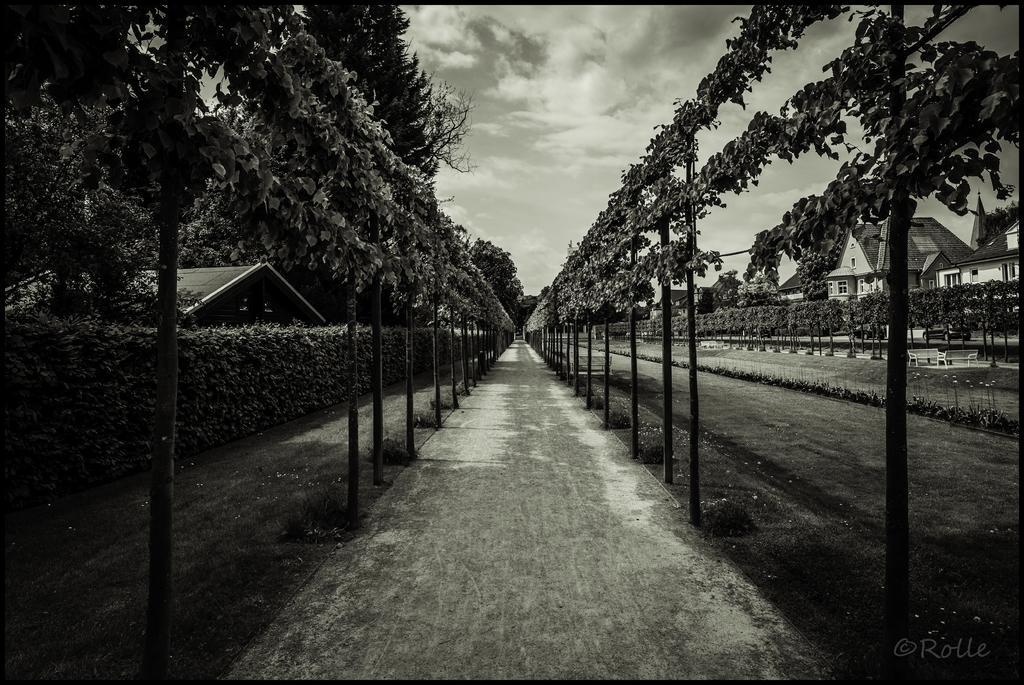Please provide a concise description of this image. In the image we can see there are buildings and trees. Here we can see planets, path and the grass. Here we can see a cloudy sky and on the bottom right we can see the watermark. 